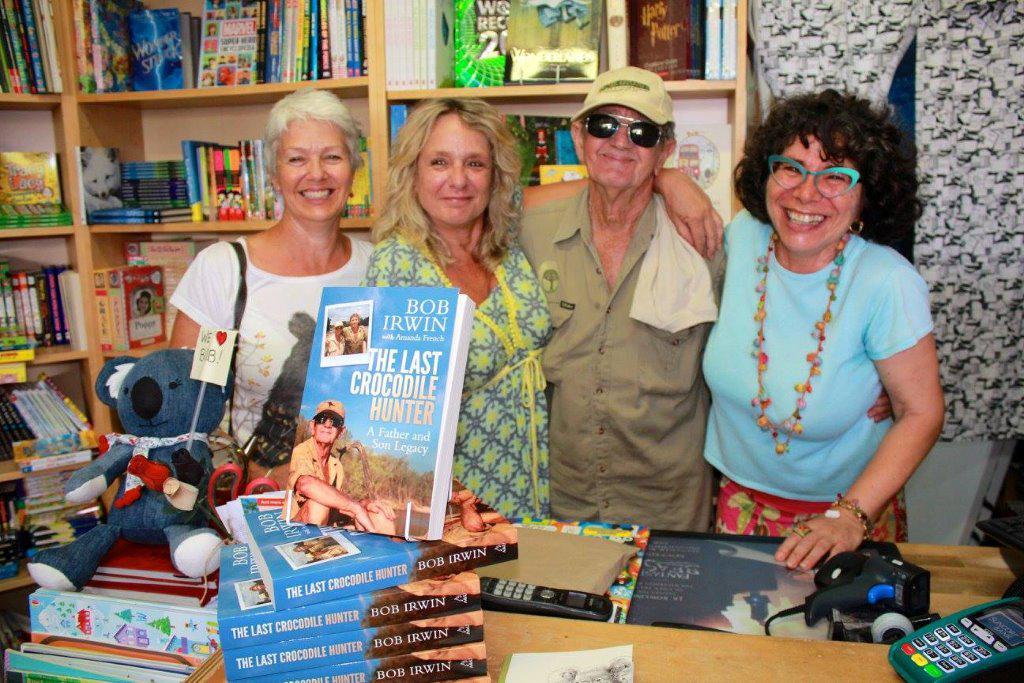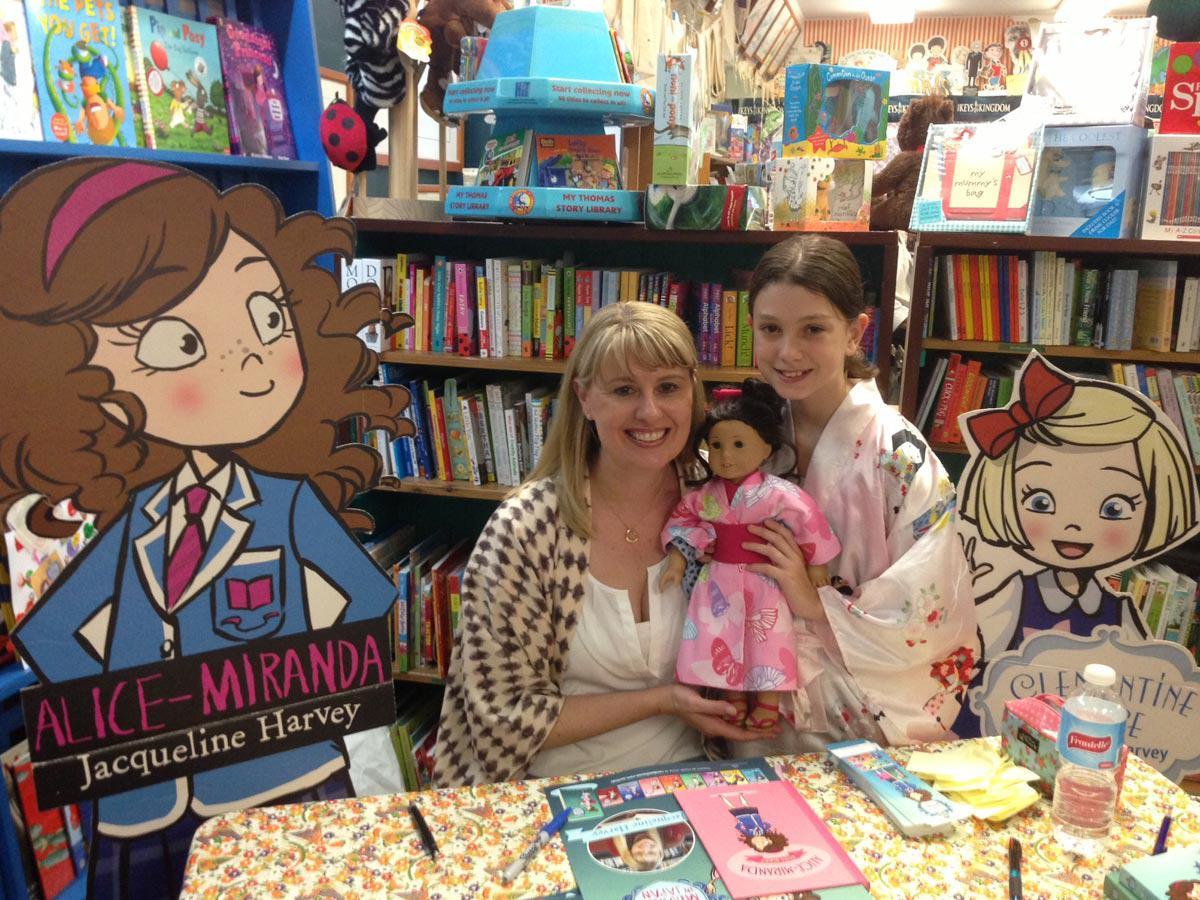The first image is the image on the left, the second image is the image on the right. For the images shown, is this caption "In one image, a blond woman has an arm around the man next to her, and a woman on the other side of him has her elbow bent, and they are standing in front of books on shelves." true? Answer yes or no. Yes. The first image is the image on the left, the second image is the image on the right. Assess this claim about the two images: "An author is posing with fans.". Correct or not? Answer yes or no. Yes. 